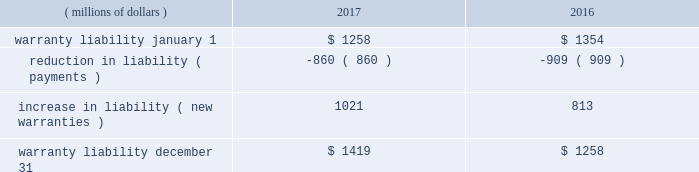2017 form 10-k | 115 and $ 1088 million , respectively , were primarily comprised of loans to dealers , and the spc 2019s liabilities of $ 1106 million and $ 1087 million , respectively , were primarily comprised of commercial paper .
The assets of the spc are not available to pay cat financial 2019s creditors .
Cat financial may be obligated to perform under the guarantee if the spc experiences losses .
No loss has been experienced or is anticipated under this loan purchase agreement .
Cat financial is party to agreements in the normal course of business with selected customers and caterpillar dealers in which they commit to provide a set dollar amount of financing on a pre- approved basis .
They also provide lines of credit to certain customers and caterpillar dealers , of which a portion remains unused as of the end of the period .
Commitments and lines of credit generally have fixed expiration dates or other termination clauses .
It has been cat financial 2019s experience that not all commitments and lines of credit will be used .
Management applies the same credit policies when making commitments and granting lines of credit as it does for any other financing .
Cat financial does not require collateral for these commitments/ lines , but if credit is extended , collateral may be required upon funding .
The amount of the unused commitments and lines of credit for dealers as of december 31 , 2017 and 2016 was $ 10993 million and $ 12775 million , respectively .
The amount of the unused commitments and lines of credit for customers as of december 31 , 2017 and 2016 was $ 3092 million and $ 3340 million , respectively .
Our product warranty liability is determined by applying historical claim rate experience to the current field population and dealer inventory .
Generally , historical claim rates are based on actual warranty experience for each product by machine model/engine size by customer or dealer location ( inside or outside north america ) .
Specific rates are developed for each product shipment month and are updated monthly based on actual warranty claim experience. .
22 .
Environmental and legal matters the company is regulated by federal , state and international environmental laws governing our use , transport and disposal of substances and control of emissions .
In addition to governing our manufacturing and other operations , these laws often impact the development of our products , including , but not limited to , required compliance with air emissions standards applicable to internal combustion engines .
We have made , and will continue to make , significant research and development and capital expenditures to comply with these emissions standards .
We are engaged in remedial activities at a number of locations , often with other companies , pursuant to federal and state laws .
When it is probable we will pay remedial costs at a site , and those costs can be reasonably estimated , the investigation , remediation , and operating and maintenance costs are accrued against our earnings .
Costs are accrued based on consideration of currently available data and information with respect to each individual site , including available technologies , current applicable laws and regulations , and prior remediation experience .
Where no amount within a range of estimates is more likely , we accrue the minimum .
Where multiple potentially responsible parties are involved , we consider our proportionate share of the probable costs .
In formulating the estimate of probable costs , we do not consider amounts expected to be recovered from insurance companies or others .
We reassess these accrued amounts on a quarterly basis .
The amount recorded for environmental remediation is not material and is included in accrued expenses .
We believe there is no more than a remote chance that a material amount for remedial activities at any individual site , or at all the sites in the aggregate , will be required .
On january 7 , 2015 , the company received a grand jury subpoena from the u.s .
District court for the central district of illinois .
The subpoena requests documents and information from the company relating to , among other things , financial information concerning u.s .
And non-u.s .
Caterpillar subsidiaries ( including undistributed profits of non-u.s .
Subsidiaries and the movement of cash among u.s .
And non-u.s .
Subsidiaries ) .
The company has received additional subpoenas relating to this investigation requesting additional documents and information relating to , among other things , the purchase and resale of replacement parts by caterpillar inc .
And non-u.s .
Caterpillar subsidiaries , dividend distributions of certain non-u.s .
Caterpillar subsidiaries , and caterpillar sarl and related structures .
On march 2-3 , 2017 , agents with the department of commerce , the federal deposit insurance corporation and the internal revenue service executed search and seizure warrants at three facilities of the company in the peoria , illinois area , including its former corporate headquarters .
The warrants identify , and agents seized , documents and information related to , among other things , the export of products from the united states , the movement of products between the united states and switzerland , the relationship between caterpillar inc .
And caterpillar sarl , and sales outside the united states .
It is the company 2019s understanding that the warrants , which concern both tax and export activities , are related to the ongoing grand jury investigation .
The company is continuing to cooperate with this investigation .
The company is unable to predict the outcome or reasonably estimate any potential loss ; however , we currently believe that this matter will not have a material adverse effect on the company 2019s consolidated results of operations , financial position or liquidity .
On march 20 , 2014 , brazil 2019s administrative council for economic defense ( cade ) published a technical opinion which named 18 companies and over 100 individuals as defendants , including two subsidiaries of caterpillar inc. , mge - equipamentos e servi e7os ferrovi e1rios ltda .
( mge ) and caterpillar brasil ltda .
The publication of the technical opinion opened cade 2019s official administrative investigation into allegations that the defendants participated in anticompetitive bid activity for the construction and maintenance of metro and train networks in brazil .
While companies cannot be .
What is the net change in warranty liability during 2016? 
Computations: (1258 - 1354)
Answer: -96.0. 